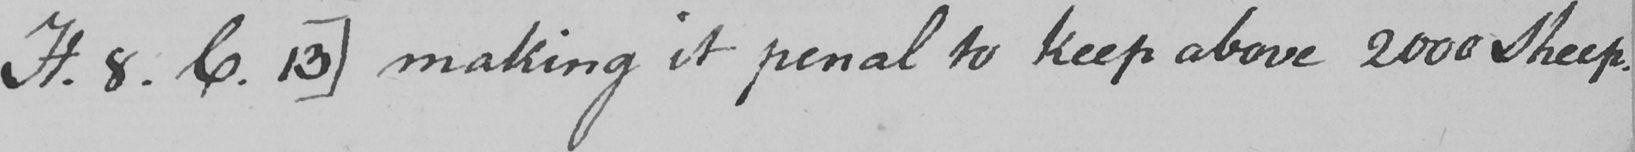Transcribe the text shown in this historical manuscript line. H . 8 . C . 13 ]  making it penal to keep above 2000 Sheep . 